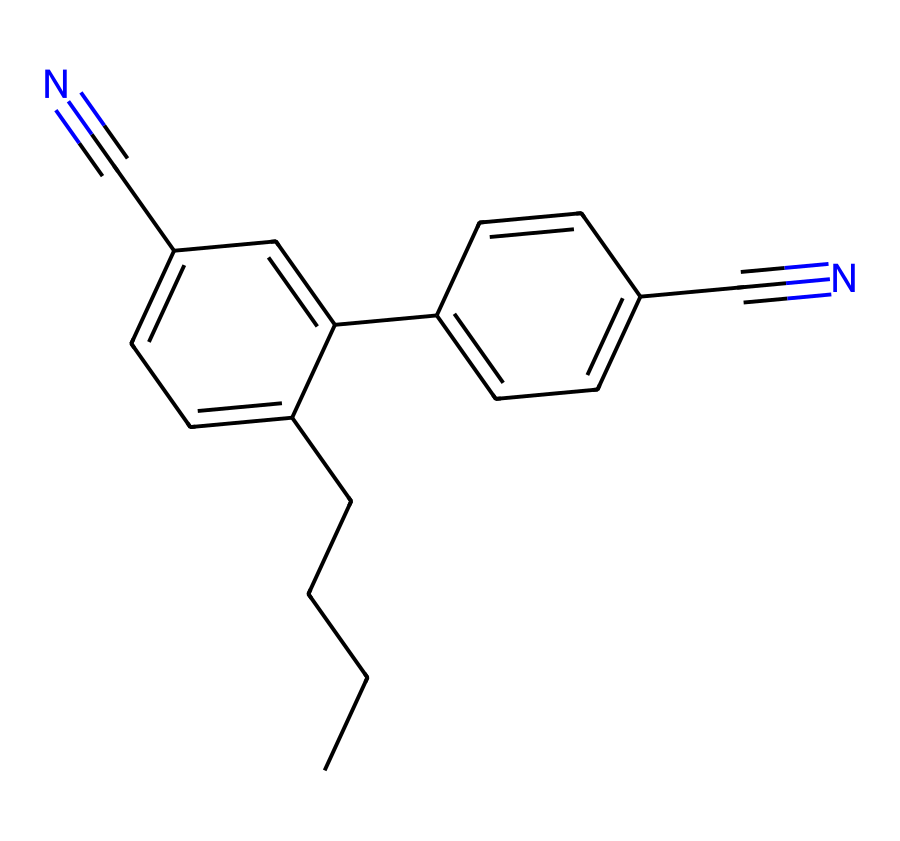What is the total number of carbon atoms in this chemical? By examining the SMILES representation, you can count the instances of the letter 'C', which indicates carbon atoms. In this particular SMILES, there are 14 'C' characters, accounting for all carbon atoms, including those in branches and rings.
Answer: 14 How many nitrogen atoms are present in this compound? The letter 'N' in the SMILES represents nitrogen atoms. By counting the occurrences of 'N', we see there are 2 nitrogen atoms in the structure.
Answer: 2 What type of bonds are present in the compound? The SMILES notation uses '=' to denote double bonds and '#' for triple bonds. In this example, there are multiple double bonds (indicated by '=') and two triple bonds (indicated by '#'). Therefore, we can conclude that the compound has double and triple bonds.
Answer: double and triple Is this compound likely to exhibit liquid crystal properties? The presence of multiple aromatic rings and the linear structure due to the alkyne (triple bond) suggests that it can have unique molecular orientations, characteristic of liquid crystals. Such structure supports the potential for liquid crystal behavior.
Answer: yes What functional groups can be identified in this chemical? The structure contains cyano groups (-C#N) that are evident from the 'C#N' in the SMILES notation. These functional groups influence the chemical's electronic properties and contribution to liquid crystal behavior.
Answer: cyano groups What is the degree of saturation in the molecule? To determine the degree of saturation, we consider the number of rings, double bonds, and triple bonds. Each ring and double bond increases saturation and each triple bond increases it further. This compound has both double and triple bonds, indicating higher saturation compared to aliphatic hydrocarbons.
Answer: high 